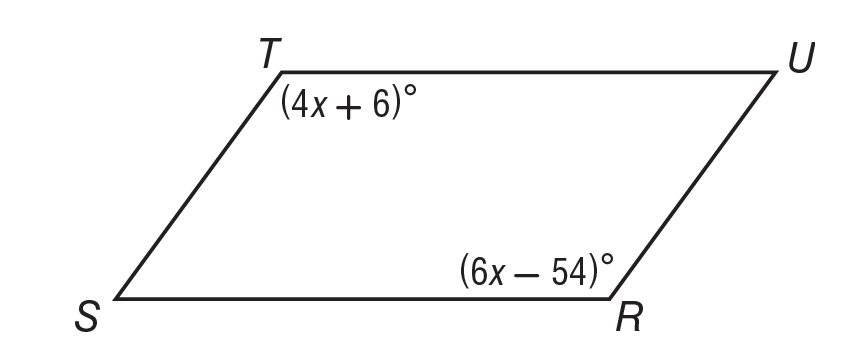Question: Solve for x in parallelogram R S T U.
Choices:
A. 12
B. 18
C. 25
D. 30
Answer with the letter. Answer: D 